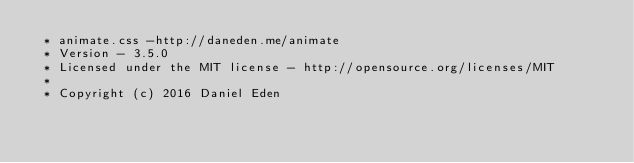<code> <loc_0><loc_0><loc_500><loc_500><_CSS_> * animate.css -http://daneden.me/animate
 * Version - 3.5.0
 * Licensed under the MIT license - http://opensource.org/licenses/MIT
 *
 * Copyright (c) 2016 Daniel Eden</code> 